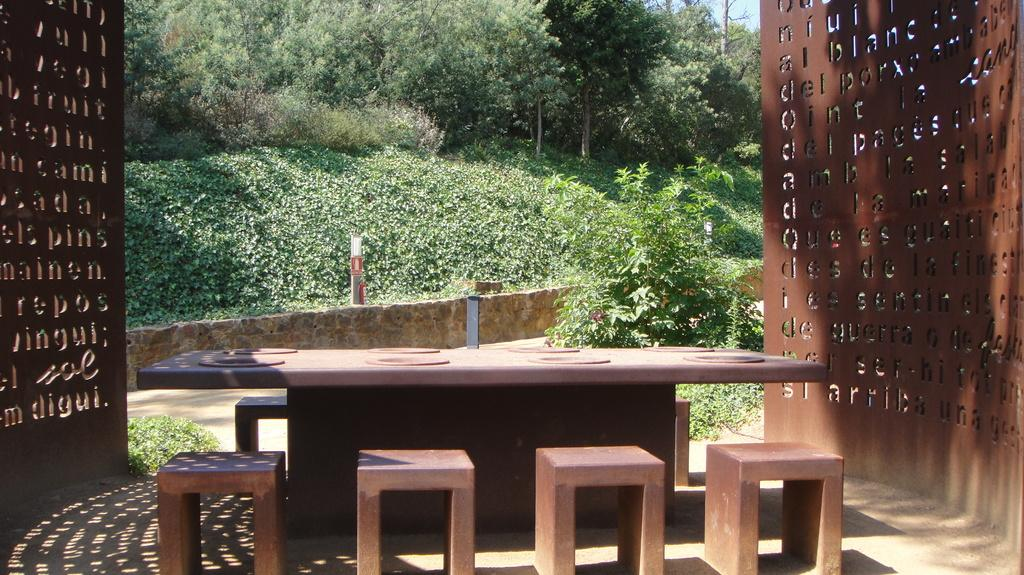What type of furniture is present in the image? There is a table and chairs in the image. What can be seen in the background of the image? Trees are visible in the background of the image. What architectural features are present in the image? There are walls on either side of the image. How many passengers are sitting on the chairs in the image? There is no indication of passengers in the image; it only shows a table and chairs. 